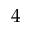<formula> <loc_0><loc_0><loc_500><loc_500>4</formula> 